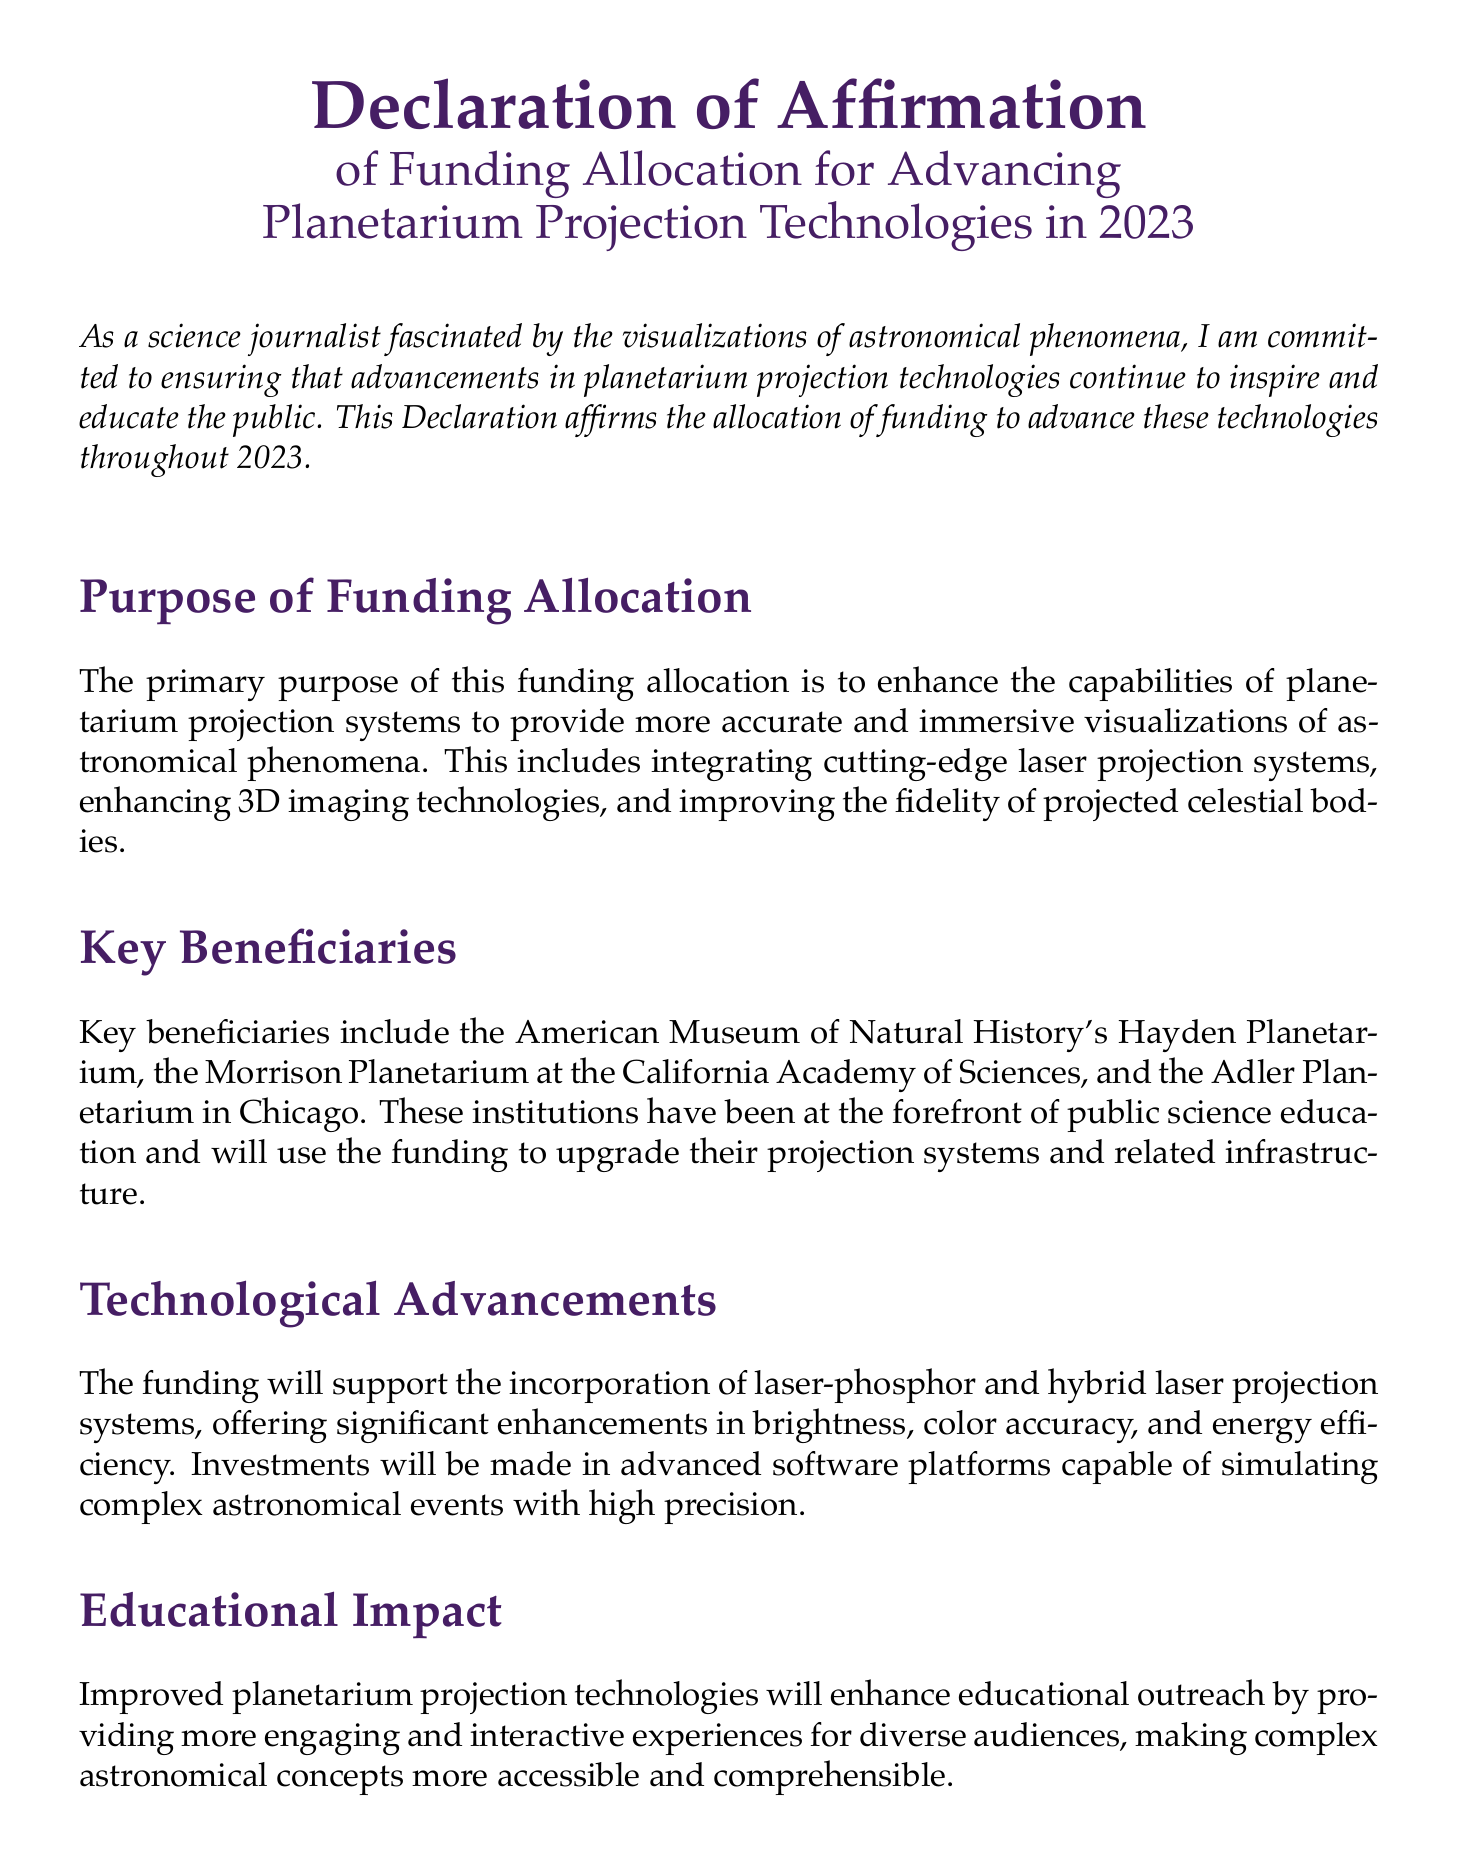What is the total funding allocation for the initiative? The total funding allocation mentioned in the document is specified as $10 million.
Answer: $10 million What are the two types of projection systems supported by the funding? The document states that funding will support laser-phosphor and hybrid laser projection systems.
Answer: laser-phosphor and hybrid laser Which institutions are key beneficiaries of the funding? The document lists the American Museum of Natural History's Hayden Planetarium, the Morrison Planetarium, and the Adler Planetarium as key beneficiaries.
Answer: American Museum of Natural History's Hayden Planetarium, Morrison Planetarium, Adler Planetarium What is the primary purpose of the funding allocation? The primary purpose outlined is to enhance capabilities of planetarium projection systems for accurate and immersive visualizations.
Answer: Enhance capabilities for accurate and immersive visualizations What will the funding enhance according to the document? The document mentions that the funding will enhance educational outreach and provide engaging experiences for diverse audiences.
Answer: Educational outreach and engaging experiences 